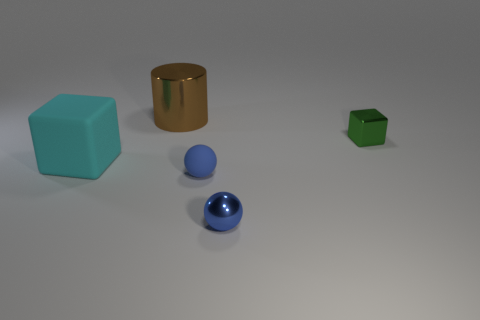Add 2 gray spheres. How many objects exist? 7 Subtract all cylinders. How many objects are left? 4 Subtract all tiny blue matte objects. Subtract all large brown objects. How many objects are left? 3 Add 3 matte things. How many matte things are left? 5 Add 2 green things. How many green things exist? 3 Subtract 0 cyan spheres. How many objects are left? 5 